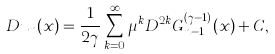Convert formula to latex. <formula><loc_0><loc_0><loc_500><loc_500>D u _ { n } ( x ) = \frac { 1 } { 2 \gamma } \sum _ { k = 0 } ^ { \infty } \mu ^ { k } D ^ { 2 k } G ^ { ( \gamma - 1 ) } _ { n - 1 } ( x ) + C ,</formula> 